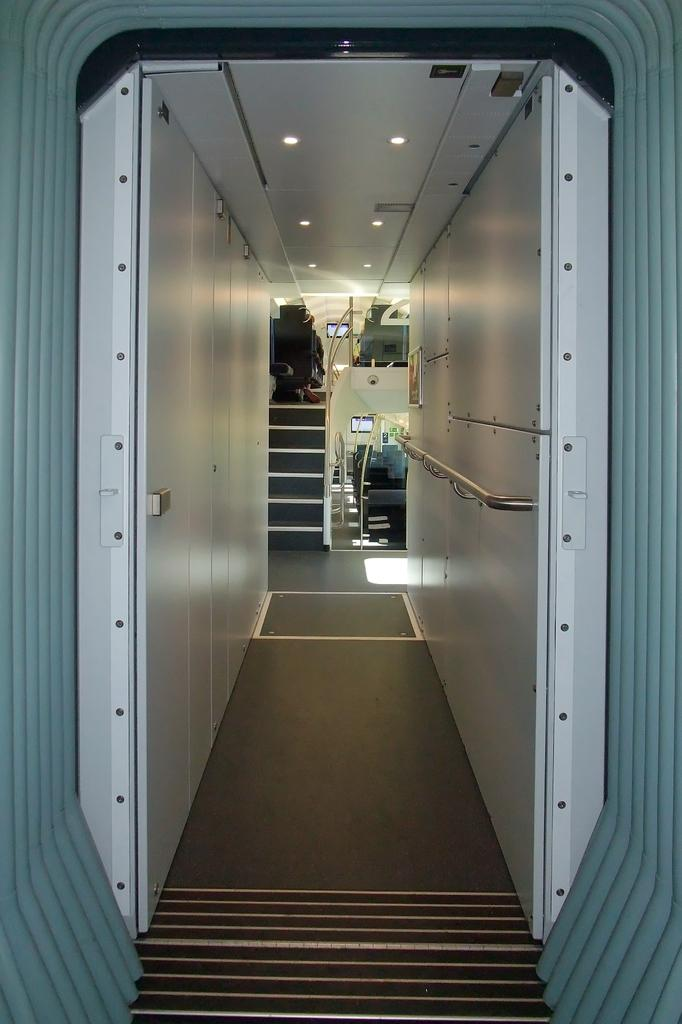What type of setting is depicted in the image? The image shows an inside view of a room. What architectural feature can be seen in the background of the room? There is a staircase visible in the background. What other objects can be seen in the background of the room? Poles and lights are present in the background. Can you see a snail crawling on the poles in the image? No, there is no snail present in the image. 